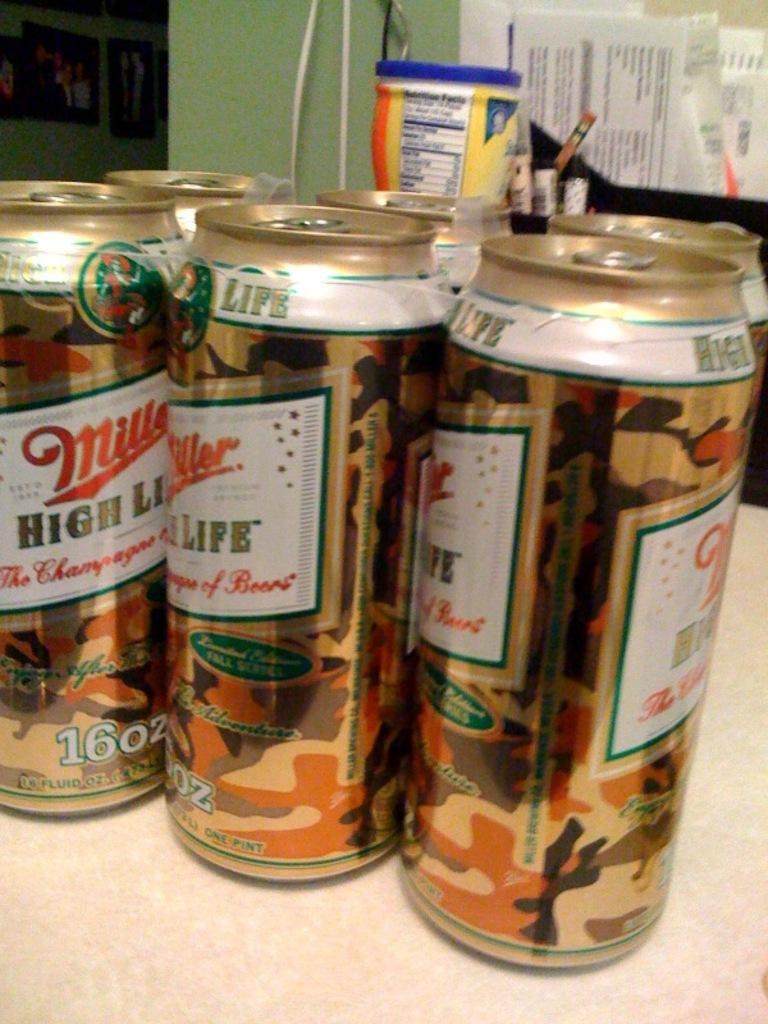<image>
Share a concise interpretation of the image provided. A six pack of Miller High Life that say 16 oz. 